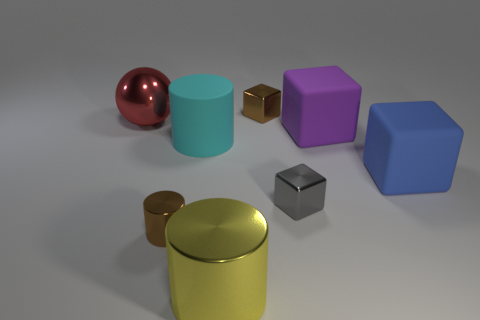Add 1 small yellow matte cubes. How many objects exist? 9 Subtract all cylinders. How many objects are left? 5 Add 1 large brown blocks. How many large brown blocks exist? 1 Subtract 1 yellow cylinders. How many objects are left? 7 Subtract all gray metal cubes. Subtract all large purple rubber objects. How many objects are left? 6 Add 5 yellow things. How many yellow things are left? 6 